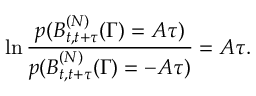<formula> <loc_0><loc_0><loc_500><loc_500>\ln \frac { p ( B _ { t , t + \tau } ^ { ( N ) } ( \Gamma ) = A \tau ) } { p ( B _ { t , t + \tau } ^ { ( N ) } ( \Gamma ) = - A \tau ) } = A \tau .</formula> 